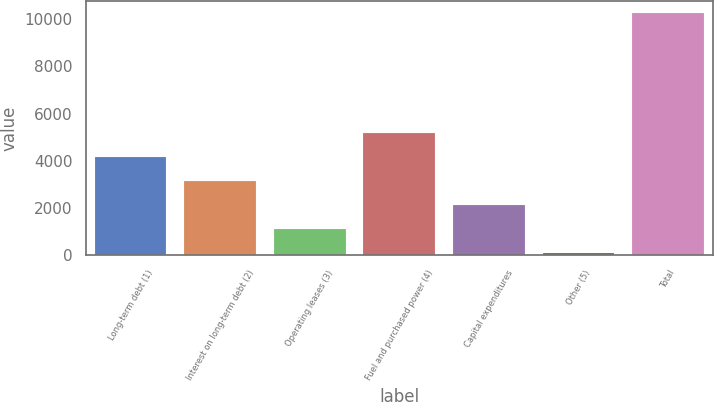Convert chart. <chart><loc_0><loc_0><loc_500><loc_500><bar_chart><fcel>Long-term debt (1)<fcel>Interest on long-term debt (2)<fcel>Operating leases (3)<fcel>Fuel and purchased power (4)<fcel>Capital expenditures<fcel>Other (5)<fcel>Total<nl><fcel>4172<fcel>3156.5<fcel>1125.5<fcel>5187.5<fcel>2141<fcel>110<fcel>10265<nl></chart> 